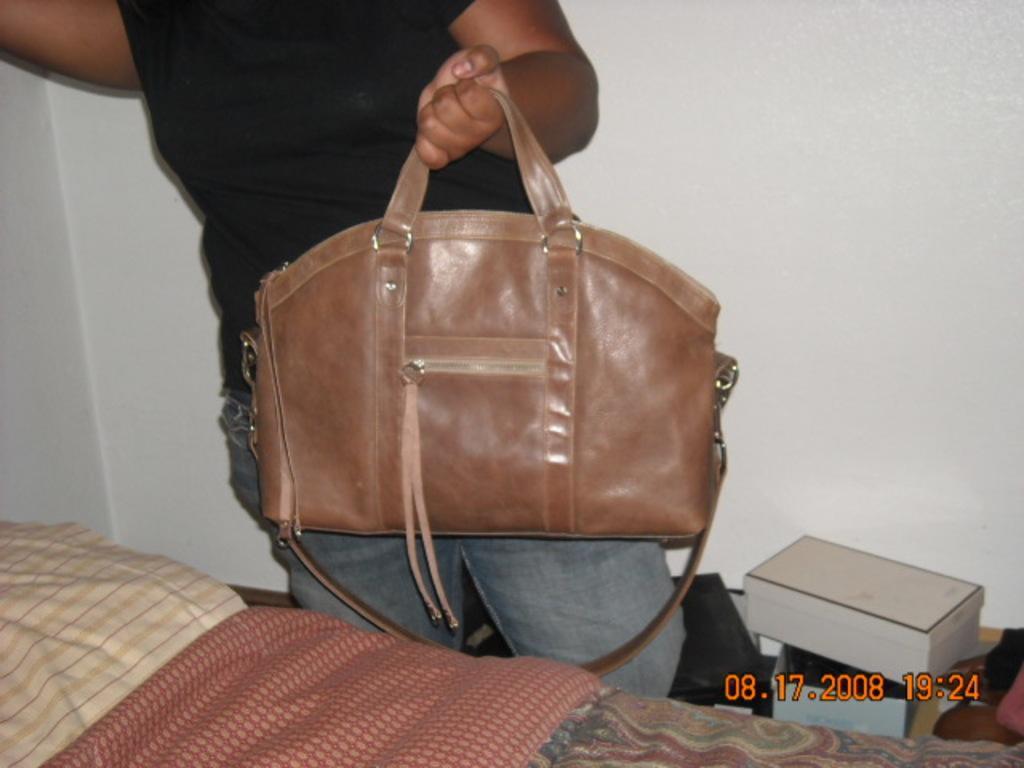How would you summarize this image in a sentence or two? Here we can see a person holding a handbag in hand and in front her we can see a bed 